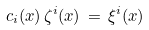Convert formula to latex. <formula><loc_0><loc_0><loc_500><loc_500>c _ { i } ( x ) \, \zeta ^ { i } ( x ) \, = \, \xi ^ { i } ( x )</formula> 